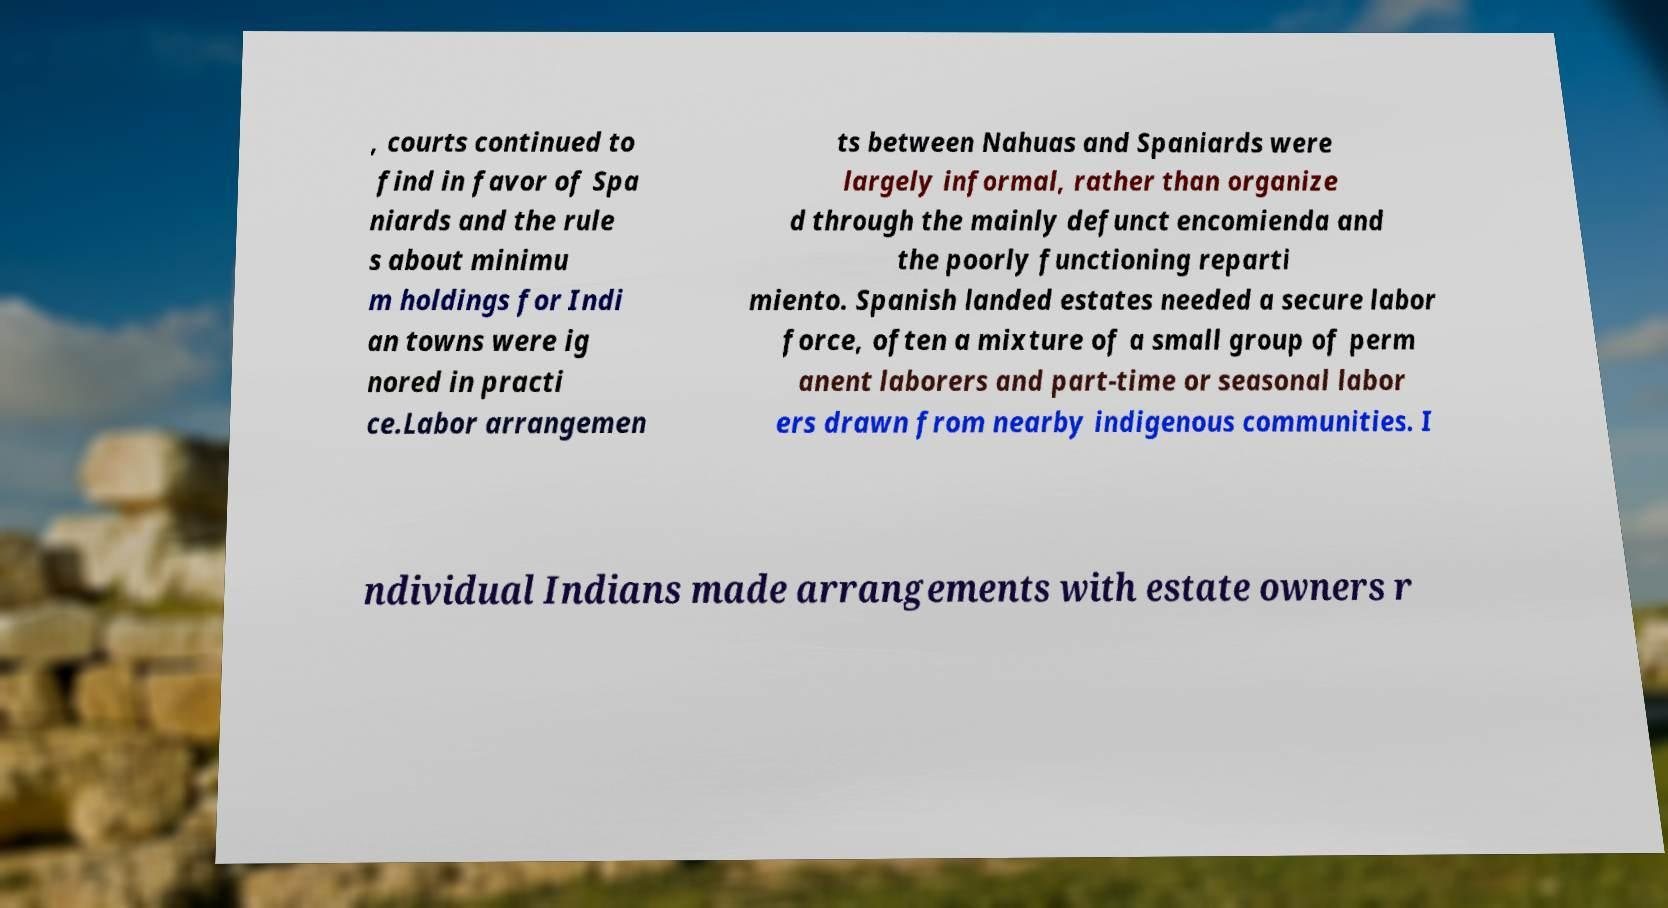Could you extract and type out the text from this image? , courts continued to find in favor of Spa niards and the rule s about minimu m holdings for Indi an towns were ig nored in practi ce.Labor arrangemen ts between Nahuas and Spaniards were largely informal, rather than organize d through the mainly defunct encomienda and the poorly functioning reparti miento. Spanish landed estates needed a secure labor force, often a mixture of a small group of perm anent laborers and part-time or seasonal labor ers drawn from nearby indigenous communities. I ndividual Indians made arrangements with estate owners r 